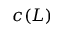Convert formula to latex. <formula><loc_0><loc_0><loc_500><loc_500>c ( L )</formula> 